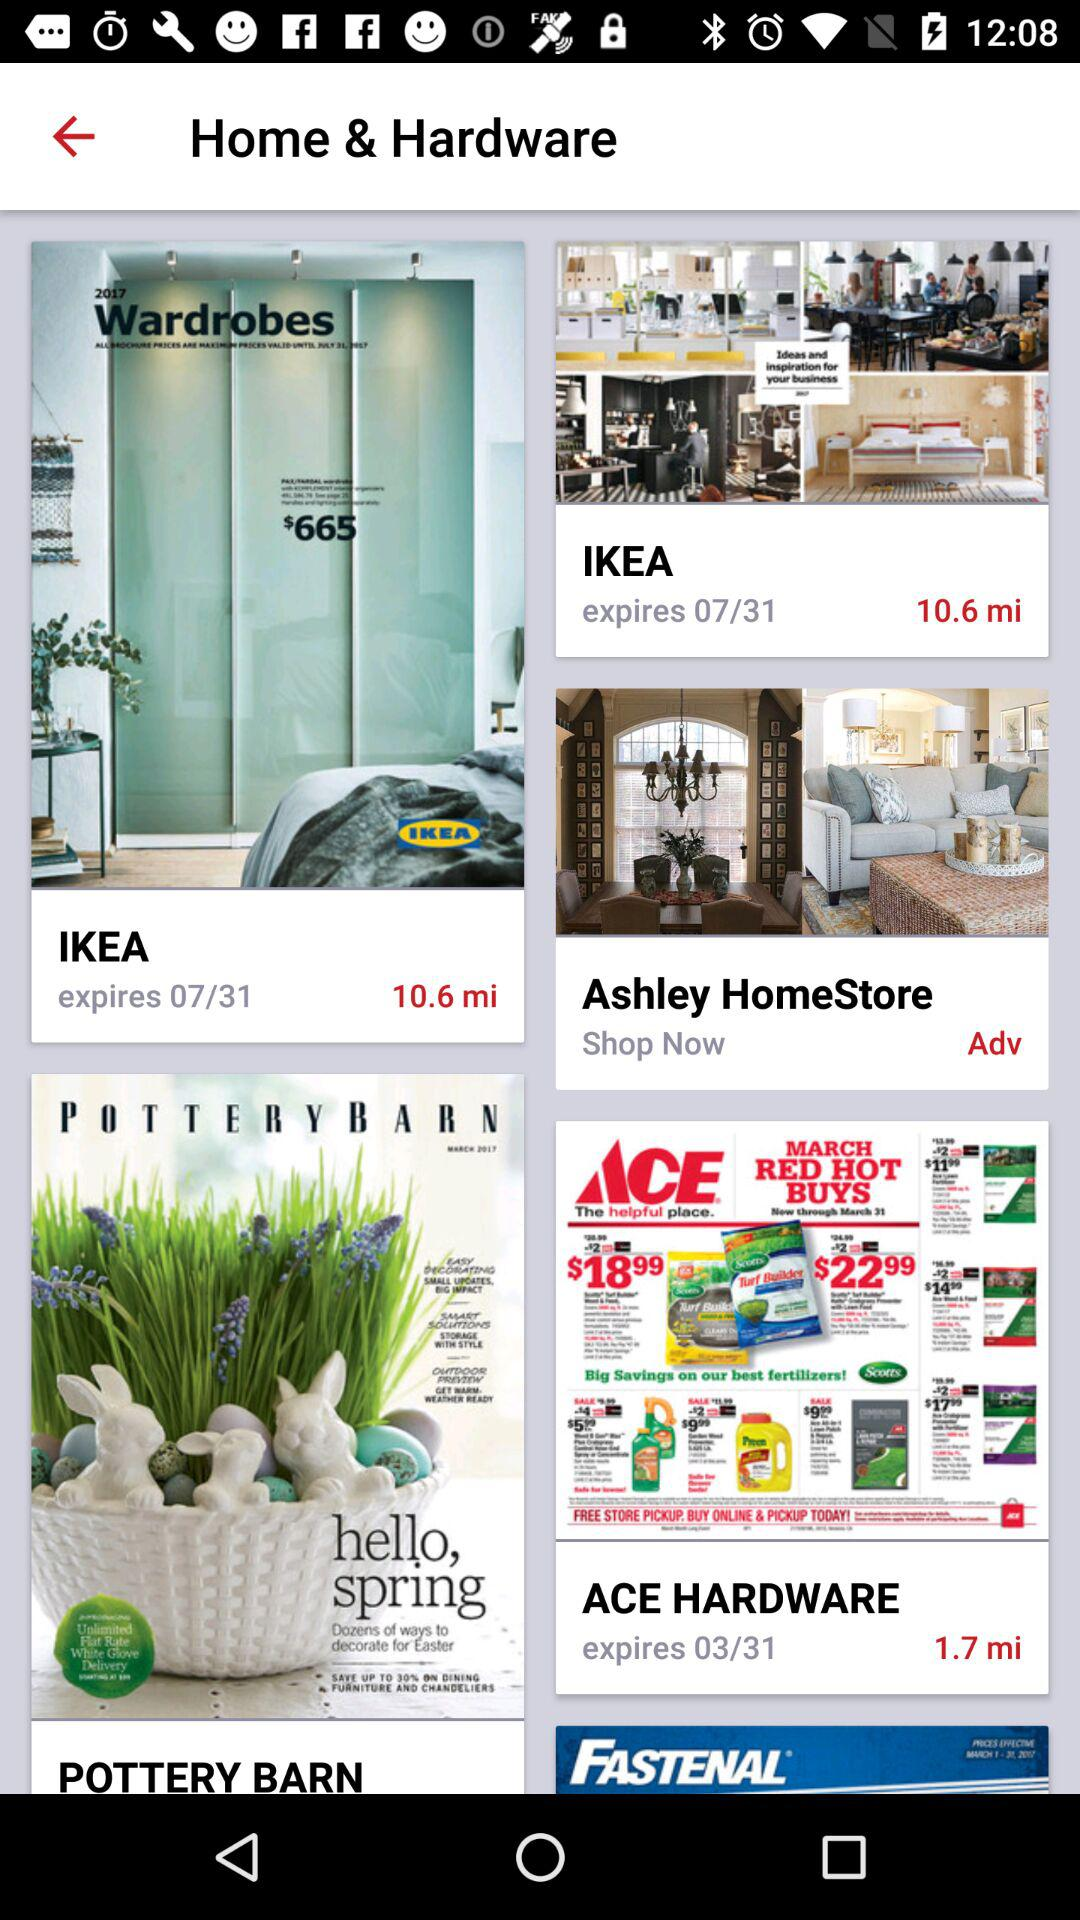How far is it to Pottery Barn?
When the provided information is insufficient, respond with <no answer>. <no answer> 